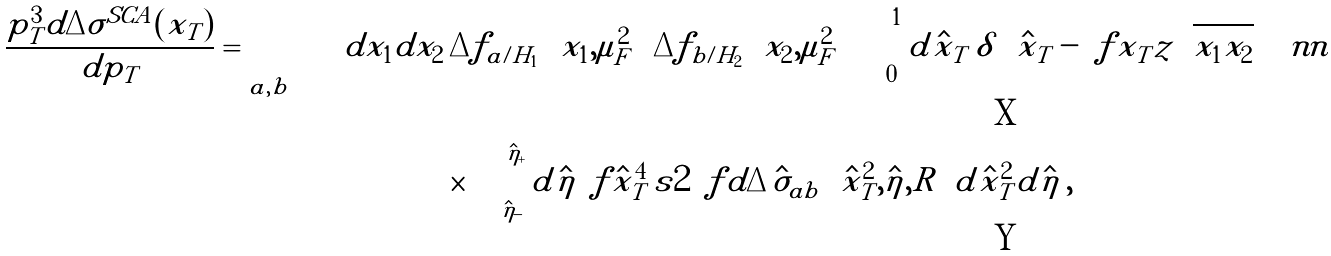<formula> <loc_0><loc_0><loc_500><loc_500>\frac { p _ { T } ^ { 3 } d \Delta \sigma ^ { S C A } ( x _ { T } ) } { d p _ { T } } = \sum _ { a , b } \, \int d x _ { 1 } d x _ { 2 } & \, \Delta f _ { a / H _ { 1 } } \left ( x _ { 1 } , \mu _ { F } ^ { 2 } \right ) \Delta f _ { b / H _ { 2 } } \left ( x _ { 2 } , \mu _ { F } ^ { 2 } \right ) \int _ { 0 } ^ { 1 } d \hat { x } _ { T } \, \delta \left ( \hat { x } _ { T } - \ f { x _ { T } } { z \sqrt { x _ { 1 } x _ { 2 } } } \right ) \, \ n n \\ & \times \int _ { \hat { \eta } _ { - } } ^ { \hat { \eta } _ { + } } d \hat { \eta } \, \ f { \hat { x } _ { T } ^ { 4 } \, s } { 2 } \, \ f { d \Delta \hat { \sigma } _ { a b } \left ( \hat { x } _ { T } ^ { 2 } , \hat { \eta } , R \right ) } { d \hat { x } _ { T } ^ { 2 } d \hat { \eta } } \, ,</formula> 